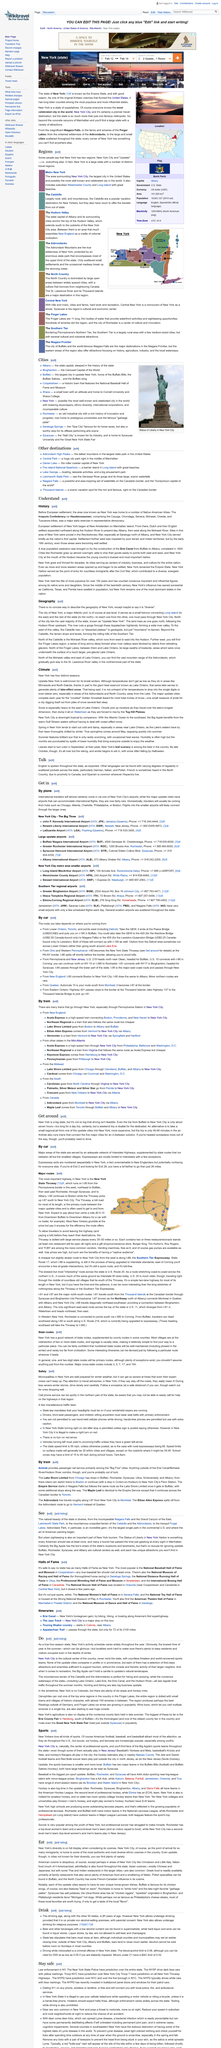Outline some significant characteristics in this image. The European settlement of New York began in 1626 at New Amsterdam on Manhattan Island, which is now the borough of Manhattan in New York City. New York is located at sea level because it is a major Atlantic port city that relies heavily on maritime trade and commerce. The busiest season in New York's activity schedule is summer. New York City is a cultural hub that offers countless theatres and world-renowned sports teams, making it an attractive destination for tourists and residents alike. The Haudenosaunee, also known as the Iroquois Confederacy, is the Native American name for the confederacy of five tribes that originally inhabited the eastern woodlands of North America. 